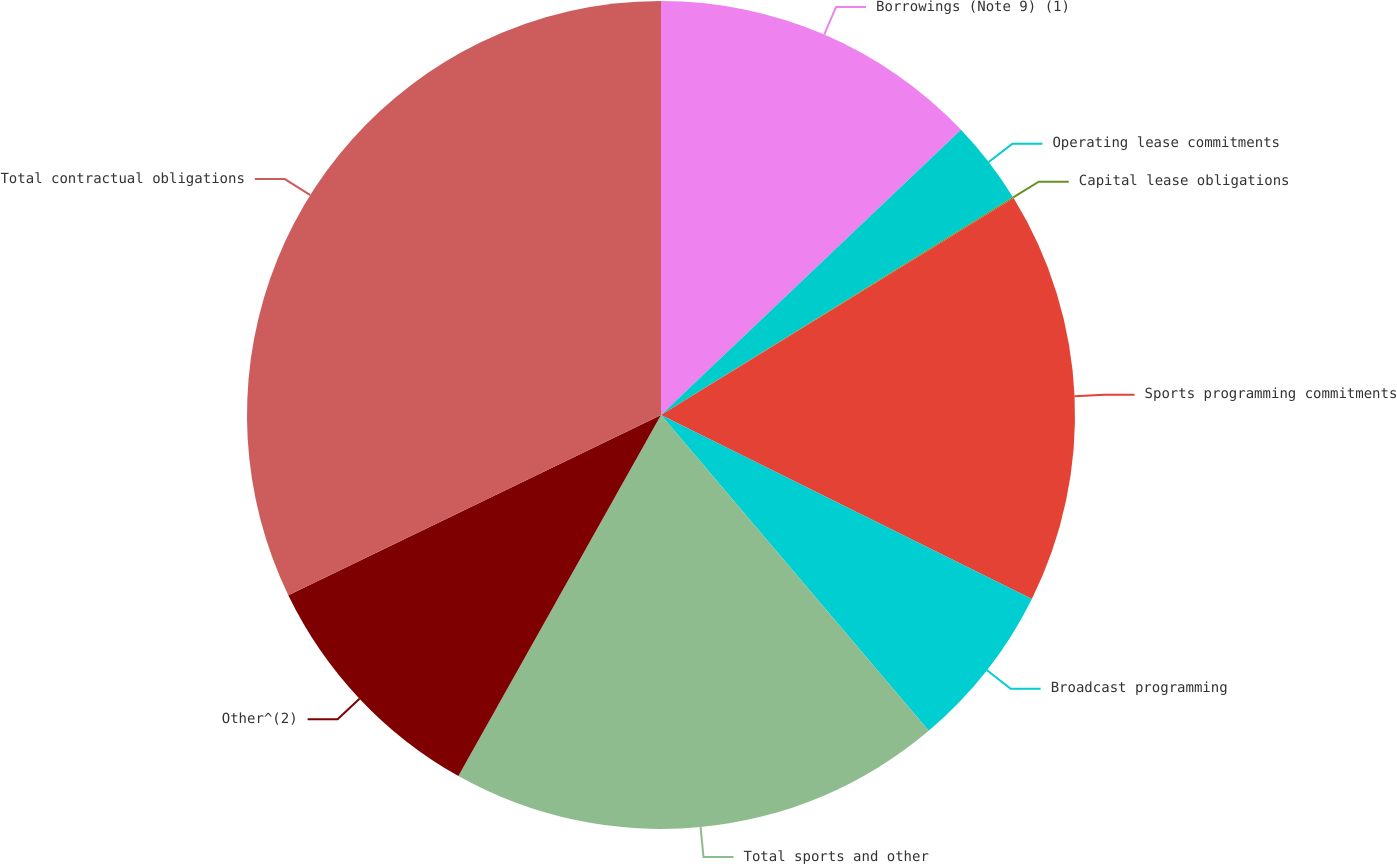Convert chart to OTSL. <chart><loc_0><loc_0><loc_500><loc_500><pie_chart><fcel>Borrowings (Note 9) (1)<fcel>Operating lease commitments<fcel>Capital lease obligations<fcel>Sports programming commitments<fcel>Broadcast programming<fcel>Total sports and other<fcel>Other^(2)<fcel>Total contractual obligations<nl><fcel>12.9%<fcel>3.27%<fcel>0.05%<fcel>16.11%<fcel>6.48%<fcel>19.33%<fcel>9.69%<fcel>32.17%<nl></chart> 